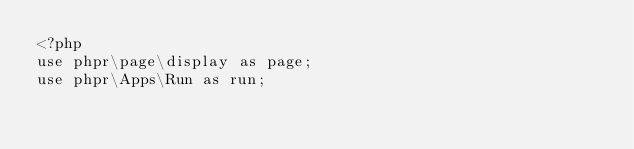<code> <loc_0><loc_0><loc_500><loc_500><_PHP_><?php
use phpr\page\display as page;
use phpr\Apps\Run as run;</code> 